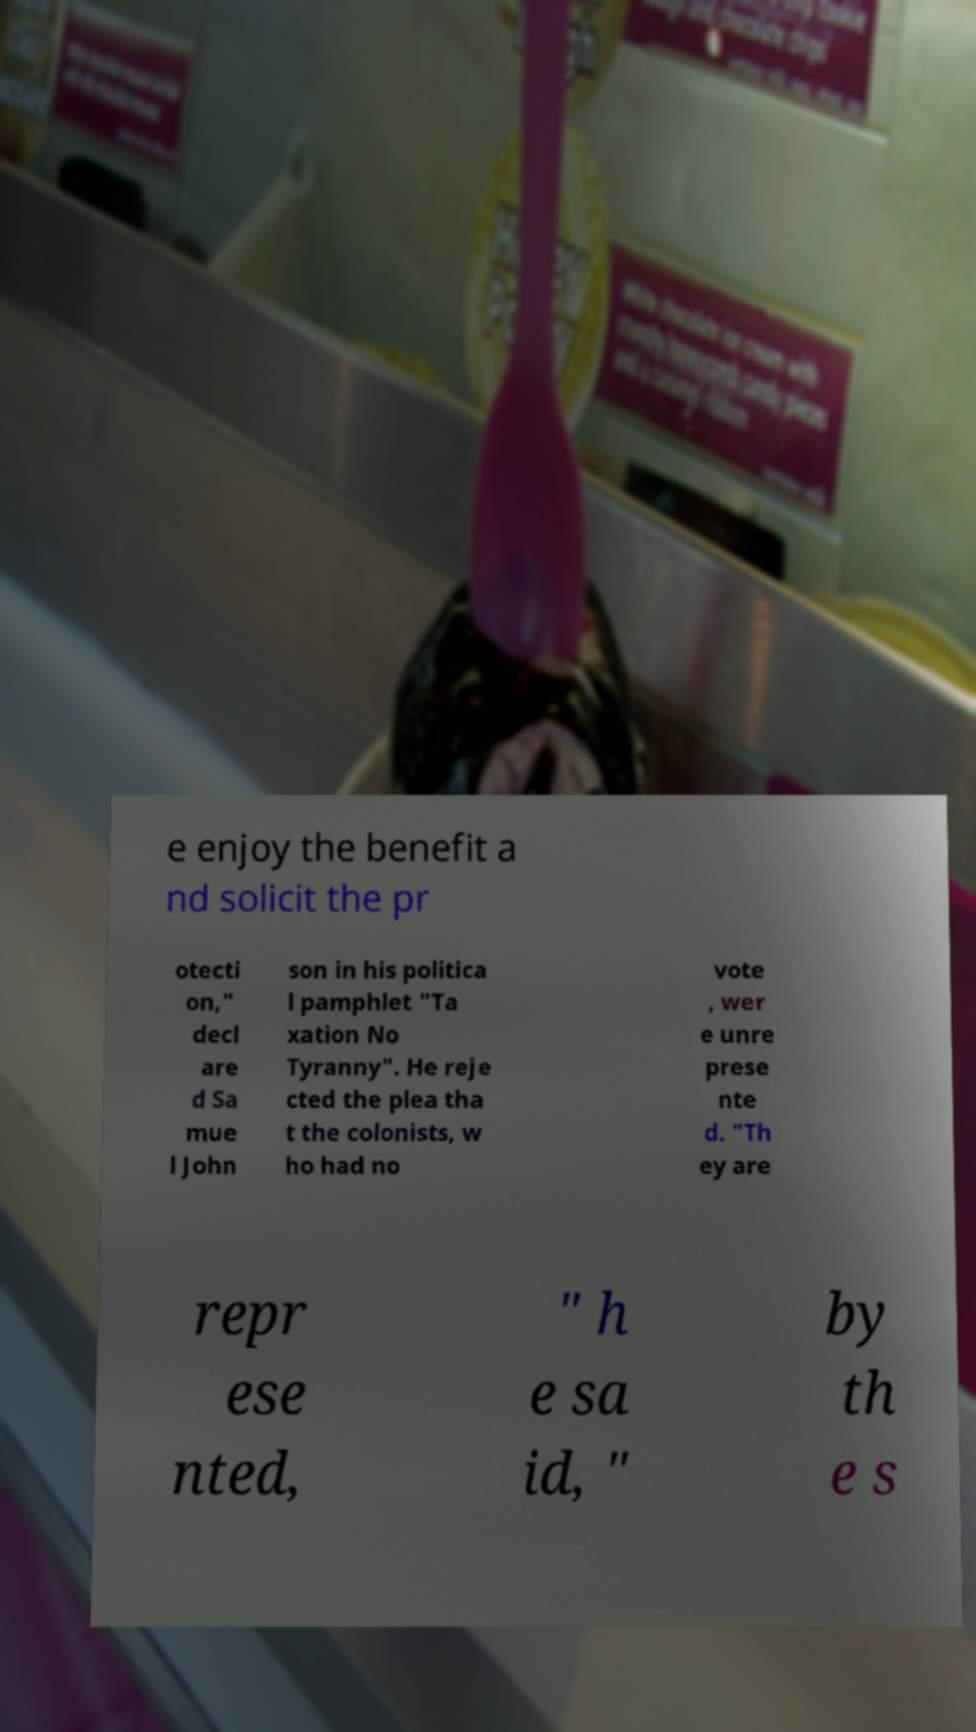What messages or text are displayed in this image? I need them in a readable, typed format. e enjoy the benefit a nd solicit the pr otecti on," decl are d Sa mue l John son in his politica l pamphlet "Ta xation No Tyranny". He reje cted the plea tha t the colonists, w ho had no vote , wer e unre prese nte d. "Th ey are repr ese nted, " h e sa id, " by th e s 